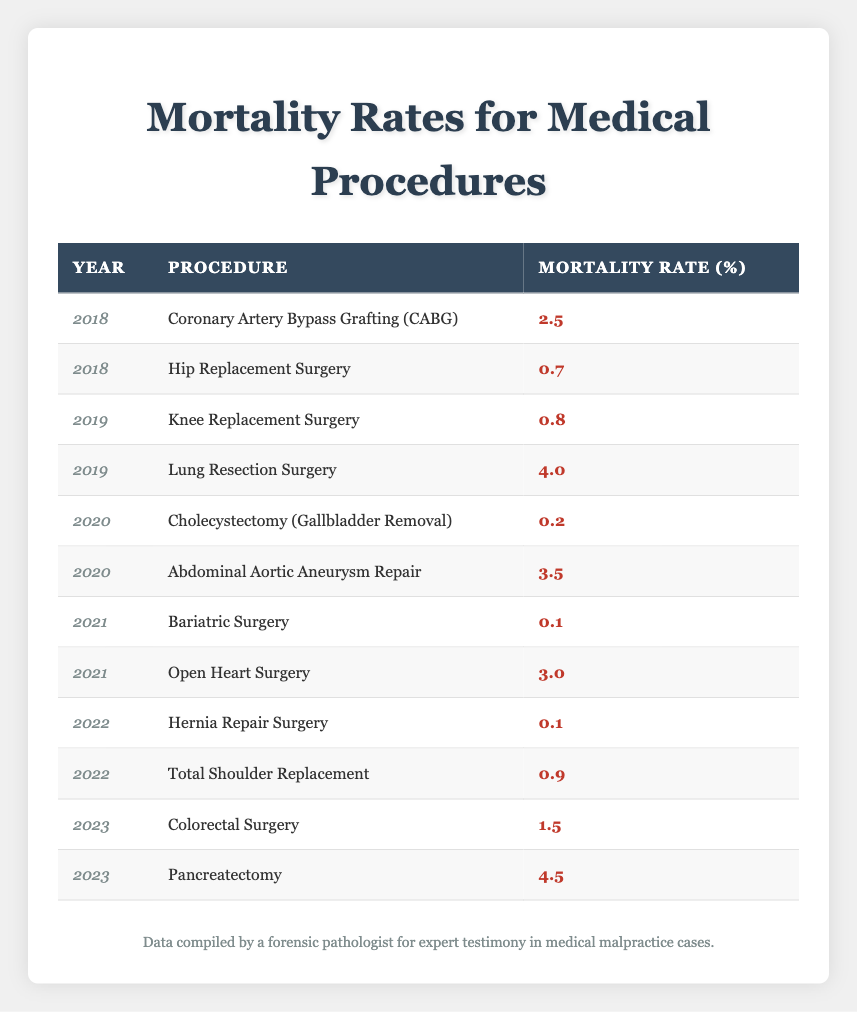What is the highest mortality rate for any procedure in the year 2020? In the year 2020, there are two procedures listed: Cholecystectomy (Gallbladder Removal) with a mortality rate of 0.2 and Abdominal Aortic Aneurysm Repair with a mortality rate of 3.5. The higher of these two rates is 3.5.
Answer: 3.5 What was the mortality rate for Coronary Artery Bypass Grafting (CABG) in 2018? The data shows that in 2018, Coronary Artery Bypass Grafting (CABG) had a mortality rate of 2.5.
Answer: 2.5 How many procedures had a mortality rate below 1 percent across all years? By inspecting each year's procedures, Hernia Repair Surgery (0.1), Bariatric Surgery (0.1), and Cholecystectomy (0.2) all have mortality rates below 1 percent. Thus, there are three procedures in total.
Answer: 3 What is the difference in mortality rates between Lung Resection Surgery in 2019 and Pancreatectomy in 2023? Lung Resection Surgery had a mortality rate of 4.0 in 2019, while Pancreatectomy had a rate of 4.5 in 2023. The difference between these rates is calculated as 4.5 - 4.0 = 0.5.
Answer: 0.5 Is the mortality rate for Total Shoulder Replacement higher than that for Hip Replacement Surgery? The data shows Total Shoulder Replacement has a mortality rate of 0.9, while Hip Replacement Surgery has a rate of 0.7. Thus, 0.9 > 0.7, making the statement true.
Answer: Yes Which year had the highest average mortality rate across the listed procedures? The average mortality rate for each year is calculated as follows: for 2018 (2.5 + 0.7) / 2 = 1.6, for 2019 (0.8 + 4.0) / 2 = 2.4, for 2020 (0.2 + 3.5) / 2 = 1.85, for 2021 (0.1 + 3.0) / 2 = 1.55, for 2022 (0.1 + 0.9) / 2 = 0.5, for 2023 (1.5 + 4.5) / 2 = 3.0. The highest average is 3.0 in 2023.
Answer: 2023 What were the mortality rates for procedures performed in the year 2021? In 2021, the two procedures are Bariatric Surgery with a mortality rate of 0.1 and Open Heart Surgery with a mortality rate of 3.0.
Answer: 0.1 and 3.0 What is the lowest mortality rate recorded in the table? Inspecting the provided data shows that the lowest mortality rate is 0.1, which occurs for both Bariatric Surgery and Hernia Repair Surgery.
Answer: 0.1 